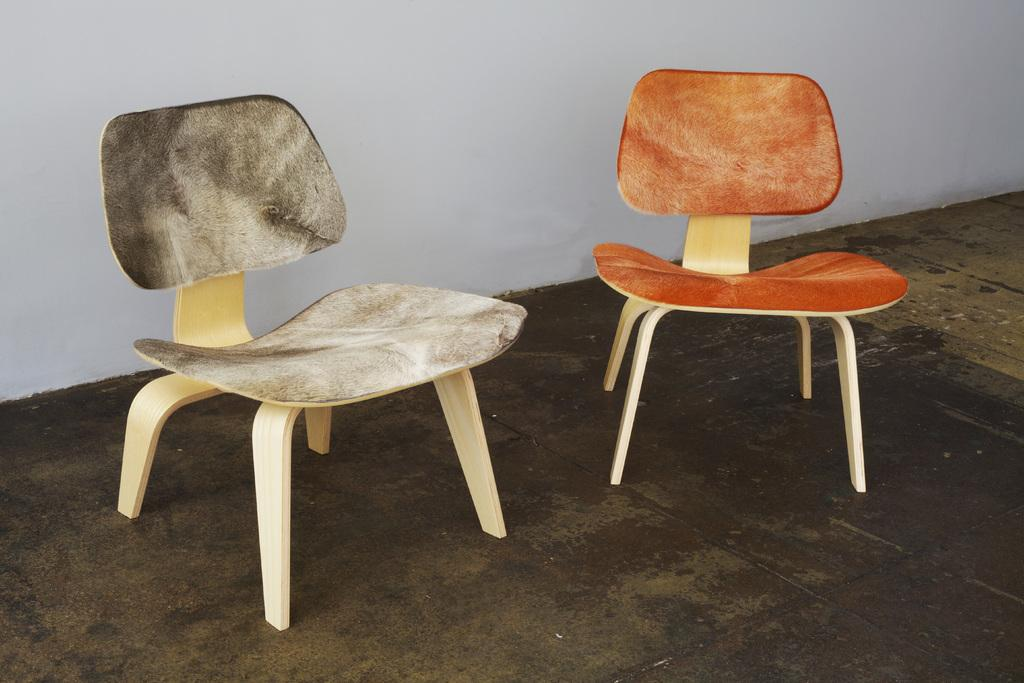How many chairs are in the image? There are two chairs in the image. What material are the chairs made of? The chairs are made of wood. Where are the chairs located in the image? The chairs are on the floor. What can be seen in the background of the image? There is a wall in the background of the image. What color is the wall? The wall is white in color. How many legs can be seen on the snakes in the image? There are no snakes present in the image, so it is not possible to determine the number of legs on any snakes. 